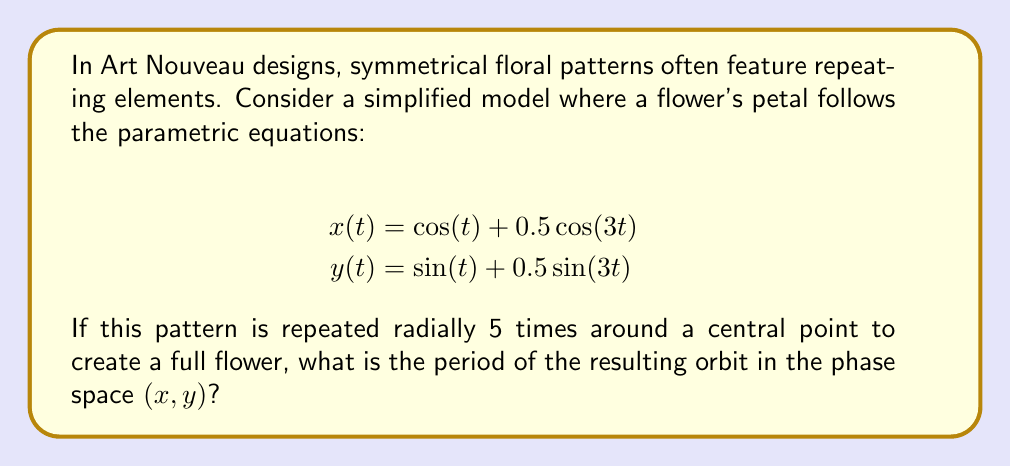Show me your answer to this math problem. To solve this problem, we need to follow these steps:

1) First, we need to understand what determines the period of the orbit. The orbit will complete one full revolution when both $x(t)$ and $y(t)$ return to their initial values simultaneously.

2) The period of $\cos(t)$ and $\sin(t)$ is $2\pi$. The period of $\cos(3t)$ and $\sin(3t)$ is $\frac{2\pi}{3}$.

3) The least common multiple (LCM) of these periods will give us the period of one petal:

   $LCM(2\pi, \frac{2\pi}{3}) = 2\pi$

4) However, we're not done yet. The question states that this pattern is repeated 5 times radially. This means that after one full revolution of $2\pi$, we will be back at the starting point of a different petal.

5) To return to the exact starting point of the original petal, we need to complete 5 full revolutions.

6) Therefore, the period of the full orbit is:

   $5 \cdot 2\pi = 10\pi$

This result means that the orbit will complete one full cycle and return to its starting point after a parameter change of $10\pi$.
Answer: $10\pi$ 